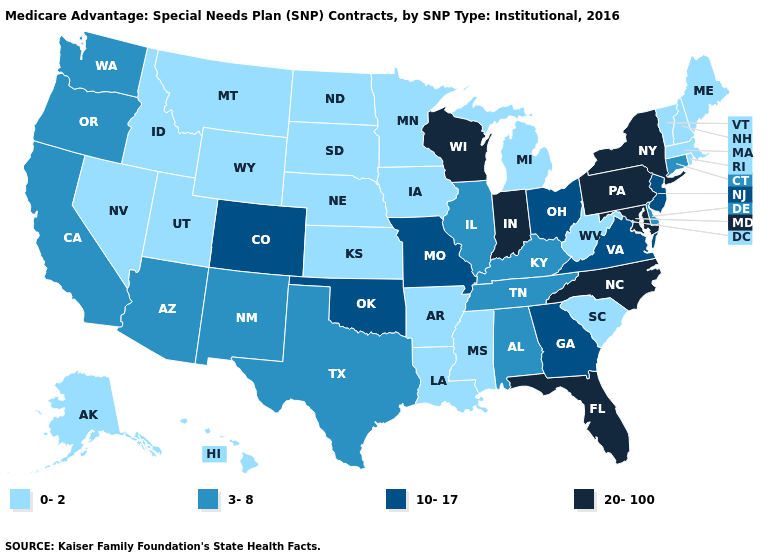Which states have the lowest value in the West?
Concise answer only. Alaska, Hawaii, Idaho, Montana, Nevada, Utah, Wyoming. Does the map have missing data?
Quick response, please. No. Among the states that border North Dakota , which have the highest value?
Be succinct. Minnesota, Montana, South Dakota. What is the highest value in the MidWest ?
Write a very short answer. 20-100. Name the states that have a value in the range 10-17?
Be succinct. Colorado, Georgia, Missouri, New Jersey, Ohio, Oklahoma, Virginia. What is the lowest value in the USA?
Quick response, please. 0-2. What is the value of New Hampshire?
Quick response, please. 0-2. Is the legend a continuous bar?
Write a very short answer. No. Among the states that border Minnesota , does Wisconsin have the lowest value?
Keep it brief. No. Among the states that border Michigan , which have the lowest value?
Be succinct. Ohio. Name the states that have a value in the range 0-2?
Concise answer only. Alaska, Arkansas, Hawaii, Iowa, Idaho, Kansas, Louisiana, Massachusetts, Maine, Michigan, Minnesota, Mississippi, Montana, North Dakota, Nebraska, New Hampshire, Nevada, Rhode Island, South Carolina, South Dakota, Utah, Vermont, West Virginia, Wyoming. Name the states that have a value in the range 0-2?
Short answer required. Alaska, Arkansas, Hawaii, Iowa, Idaho, Kansas, Louisiana, Massachusetts, Maine, Michigan, Minnesota, Mississippi, Montana, North Dakota, Nebraska, New Hampshire, Nevada, Rhode Island, South Carolina, South Dakota, Utah, Vermont, West Virginia, Wyoming. Name the states that have a value in the range 10-17?
Write a very short answer. Colorado, Georgia, Missouri, New Jersey, Ohio, Oklahoma, Virginia. Does Rhode Island have the same value as Maine?
Be succinct. Yes. 